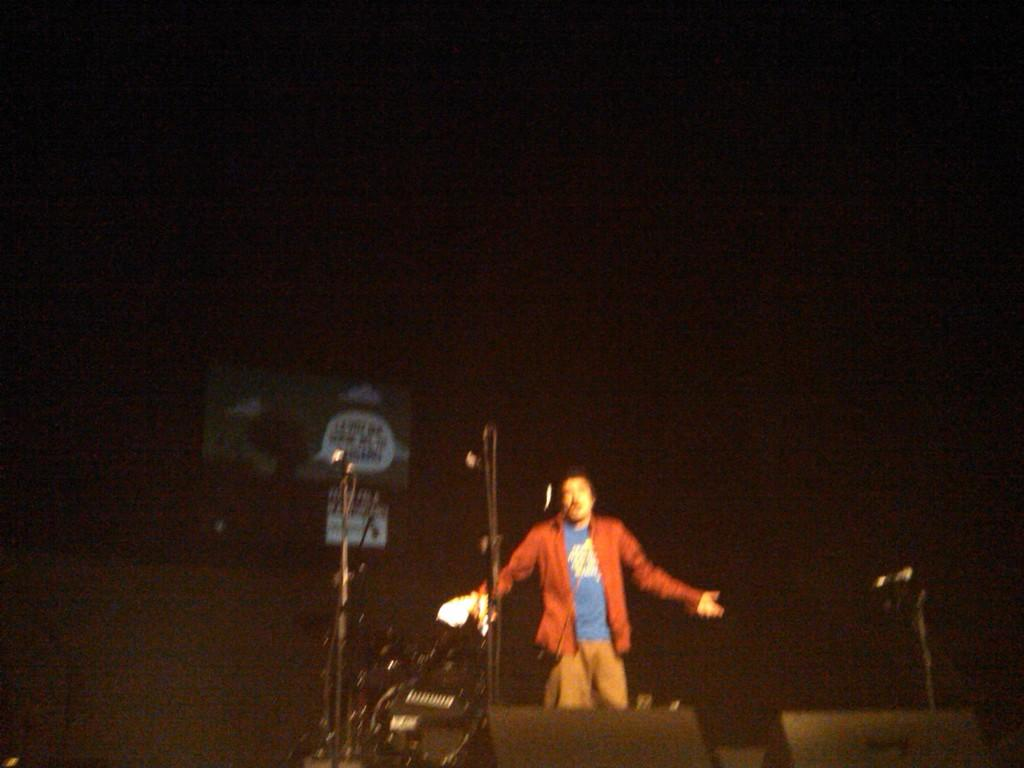What is the main subject of the image? There is a person in the image. What objects can be seen in the image besides the person? There are mics and other objects in the image. What is written on the board in the image? There is a board with text in the image. Can you describe the background of the image? The background of the image is blurred. What type of oatmeal is being served on the person's legs in the image? There is no oatmeal or legs visible in the image; it features a person with mics and other objects. How many cents can be seen on the person's forehead in the image? There are no cents or any monetary value present on the person's forehead in the image. 